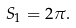Convert formula to latex. <formula><loc_0><loc_0><loc_500><loc_500>S _ { 1 } = 2 \pi .</formula> 